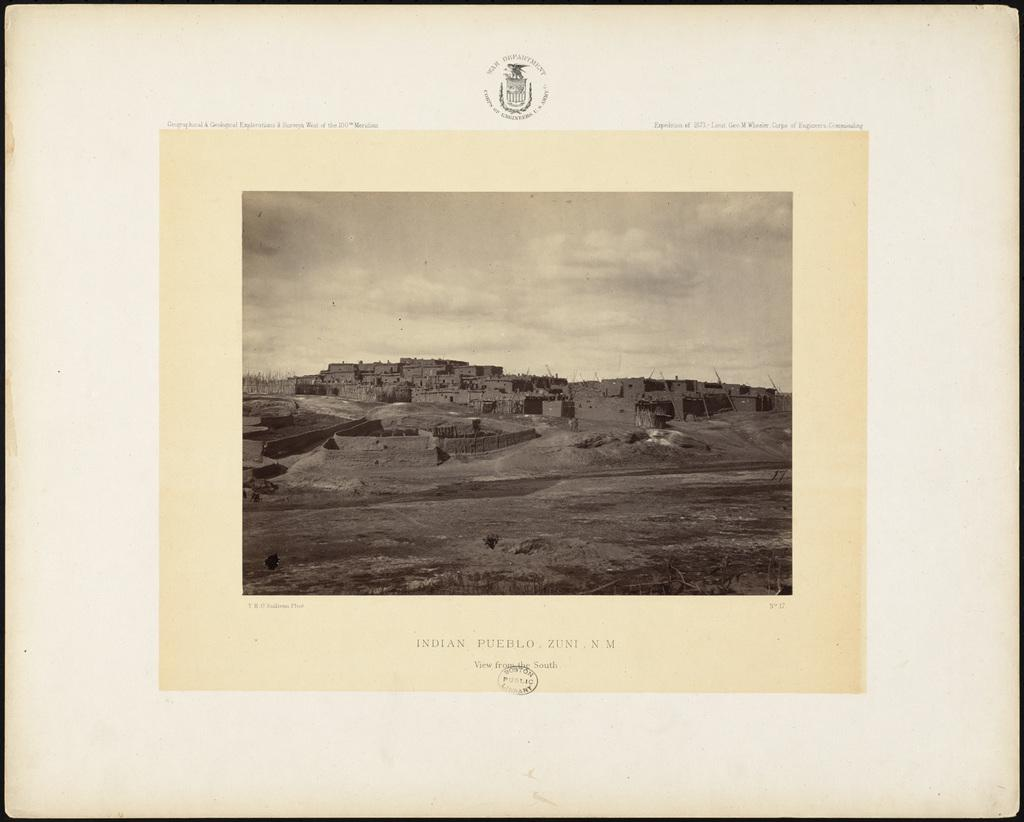<image>
Give a short and clear explanation of the subsequent image. Old photo showing buildings of Indian Pueblo Zuni. 